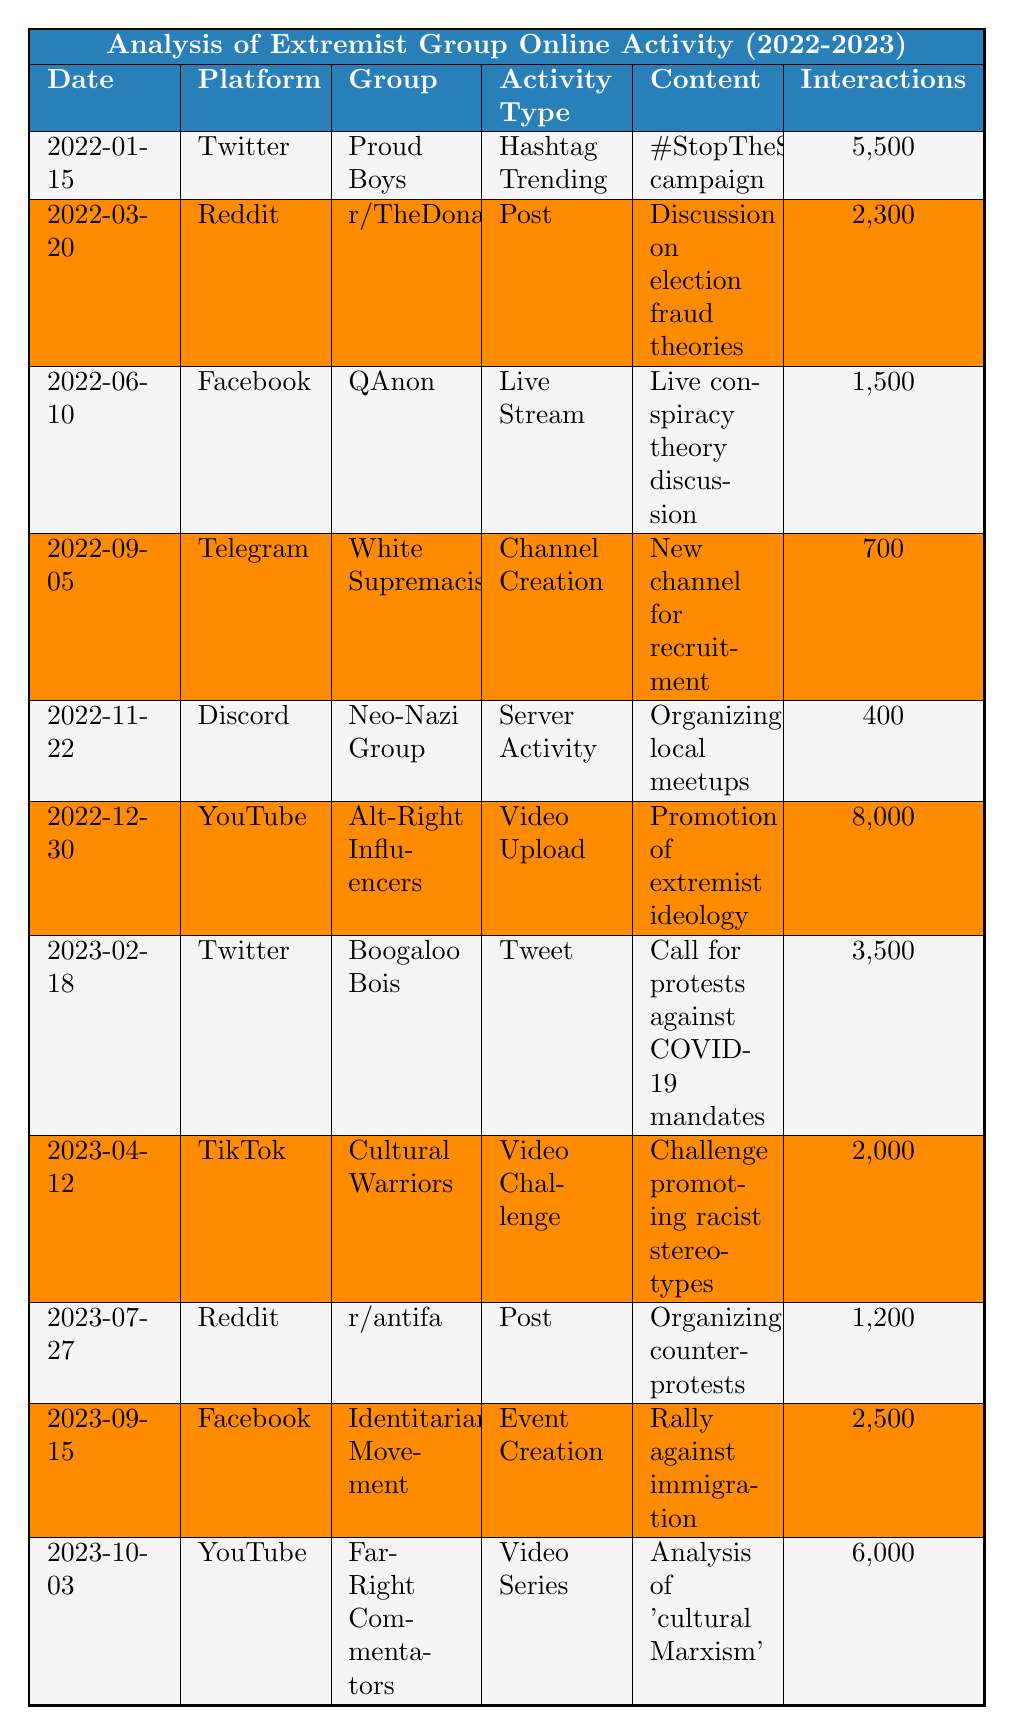What is the total interaction count for activities from the 'Alt-Right Influencers'? There is one entry for 'Alt-Right Influencers' with an interaction count of 8,000 on 2022-12-30. The total interaction count is thus 8,000.
Answer: 8000 How many times did Twitter feature extremist group activities in this data? Reviewing the table, there are three entries for Twitter: Proud Boys on 2022-01-15, Boogaloo Bois on 2023-02-18, and an additional activity also on Twitter. So, the total is 3 times.
Answer: 3 What is the interaction count of the least active group in this dataset? Among all groups, the Neo-Nazi Group on 2022-11-22 has the least interaction count at 400.
Answer: 400 Did any extremist groups use TikTok for their activities? The table shows one entry for the Cultural Warriors on 2023-04-12, indicating that TikTok was used for extremist activities.
Answer: Yes What was the maximum interaction count achieved by any single post in this dataset? The highest interaction count listed is 8,000 for the 'Alt-Right Influencers' on YouTube on 2022-12-30.
Answer: 8000 Which platform had the most activities listed in the table? The platforms can be counted as follows: Twitter (3), Reddit (2), Facebook (2), Telegram (1), Discord (1), TikTok (1), and YouTube (2). The most active platform is Twitter with 3 activities.
Answer: Twitter What is the average interaction count from the data entries? The total interactions sum to 36,500 (5500 + 2300 + 1500 + 700 + 400 + 8000 + 3500 + 2000 + 1200 + 2500 + 6000). There are 11 activities, thus the average is 36,500/11 = 3318.18.
Answer: 3318.18 How many unique extremist groups are identified in this dataset? By examining the group names in the table, there are 10 unique entries: Proud Boys, r/TheDonald, QAnon, White Supremacists, Neo-Nazi Group, Alt-Right Influencers, Boogaloo Bois, Cultural Warriors, r/antifa, and Identitarian Movement.
Answer: 10 For which group did the highest number of interactions and activities occur? The Alt-Right Influencers, with their activity on YouTube, had the highest number of interactions at 8,000. This is the only entry listed for them, so we cannot compare it with others.
Answer: Alt-Right Influencers Was there more online activity in 2023 compared to 2022 based on interaction counts? In total, the interaction counts for 2022 sum to 22,400 and for 2023 sum to 14,700. So, 2022 had more online activity overall.
Answer: No 